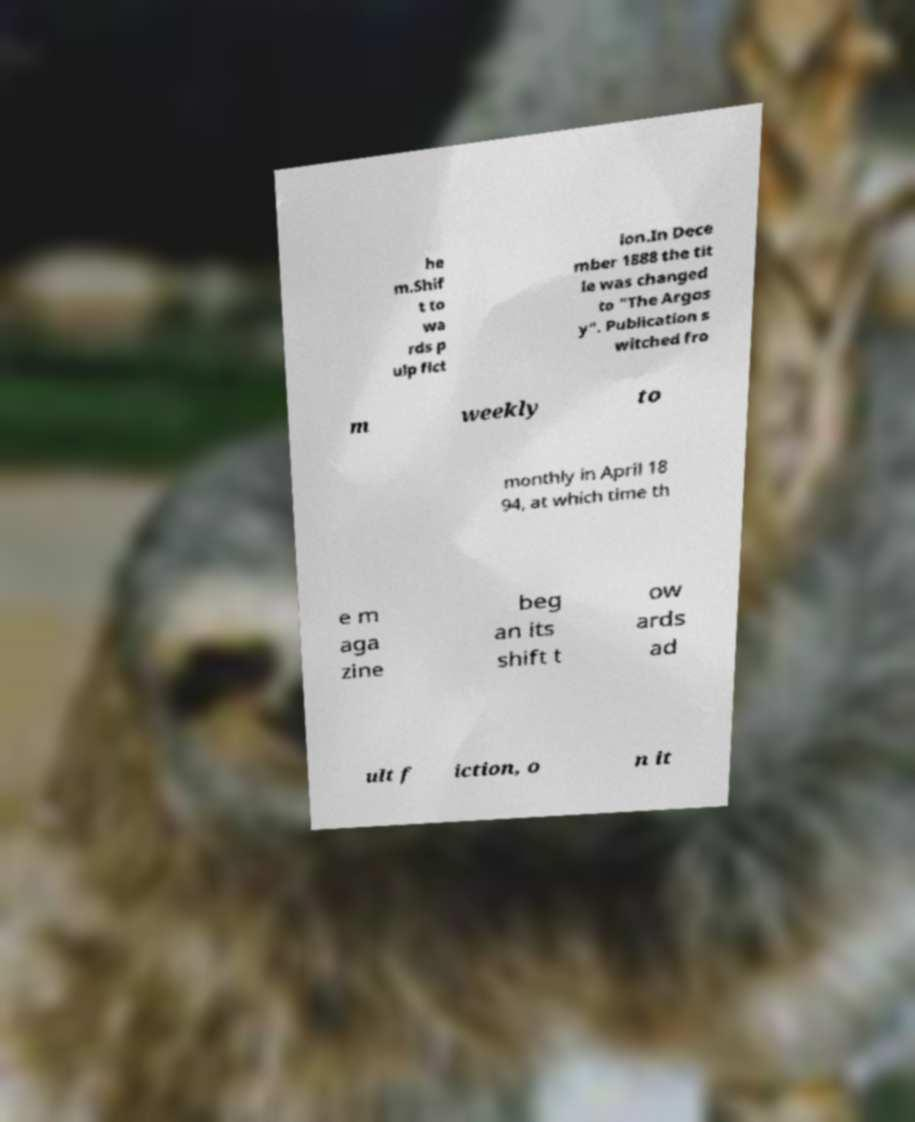What messages or text are displayed in this image? I need them in a readable, typed format. he m.Shif t to wa rds p ulp fict ion.In Dece mber 1888 the tit le was changed to "The Argos y". Publication s witched fro m weekly to monthly in April 18 94, at which time th e m aga zine beg an its shift t ow ards ad ult f iction, o n it 